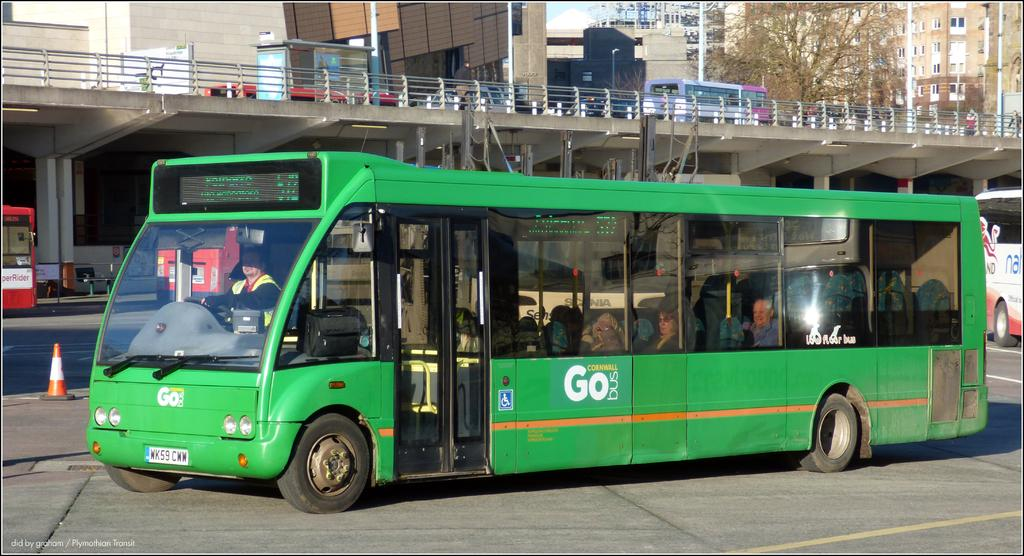Provide a one-sentence caption for the provided image. The GoBus  from Cornwall is green with huge windows. 